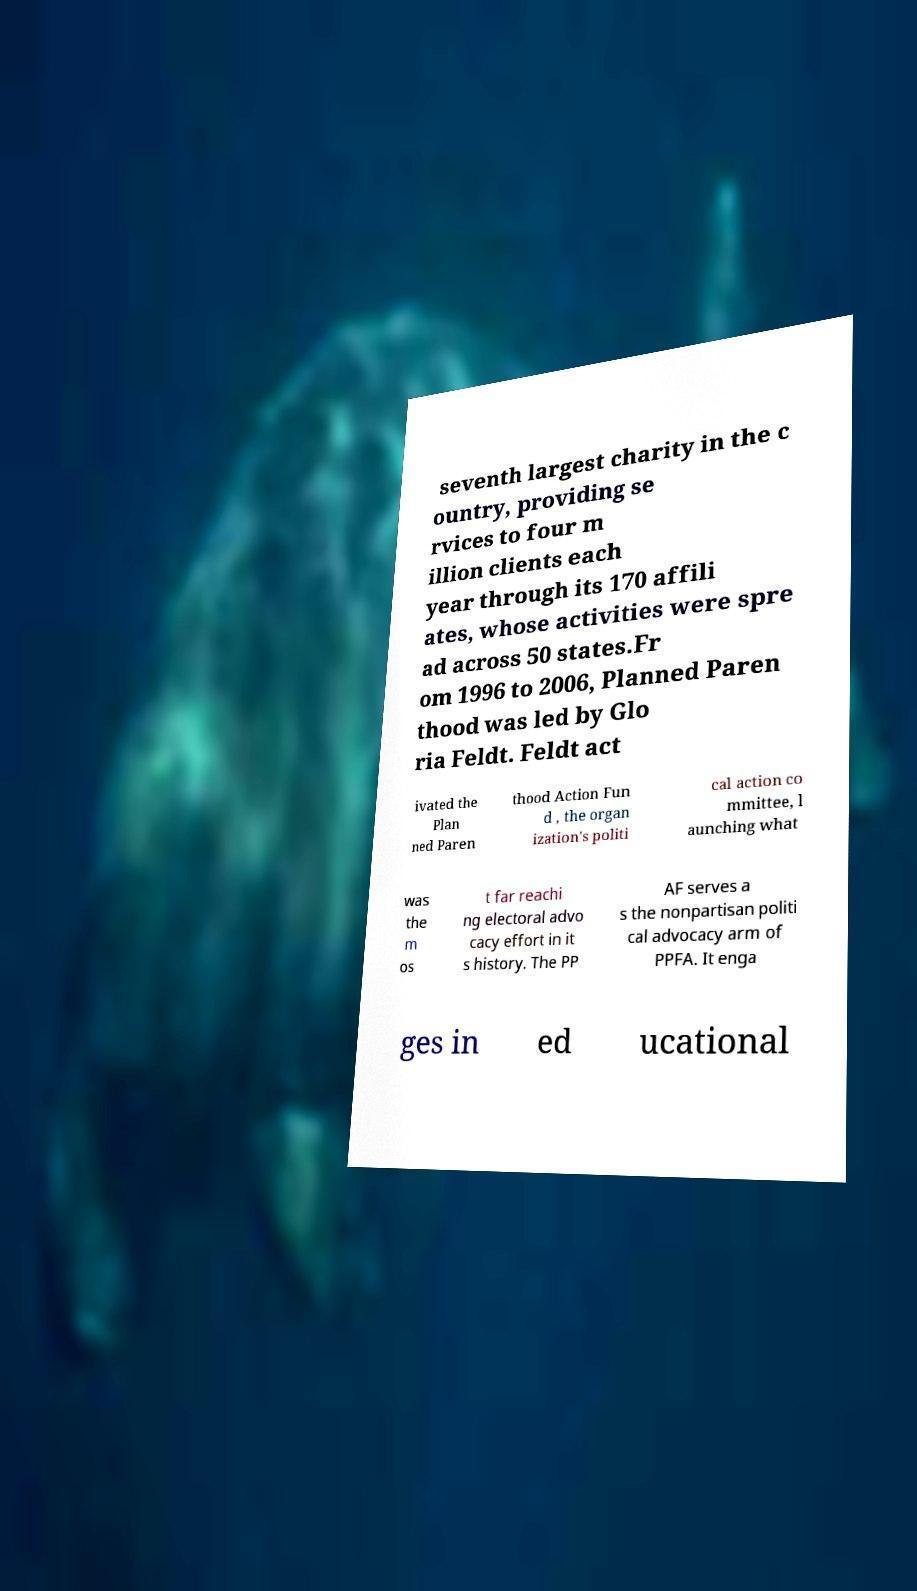What messages or text are displayed in this image? I need them in a readable, typed format. seventh largest charity in the c ountry, providing se rvices to four m illion clients each year through its 170 affili ates, whose activities were spre ad across 50 states.Fr om 1996 to 2006, Planned Paren thood was led by Glo ria Feldt. Feldt act ivated the Plan ned Paren thood Action Fun d , the organ ization's politi cal action co mmittee, l aunching what was the m os t far reachi ng electoral advo cacy effort in it s history. The PP AF serves a s the nonpartisan politi cal advocacy arm of PPFA. It enga ges in ed ucational 